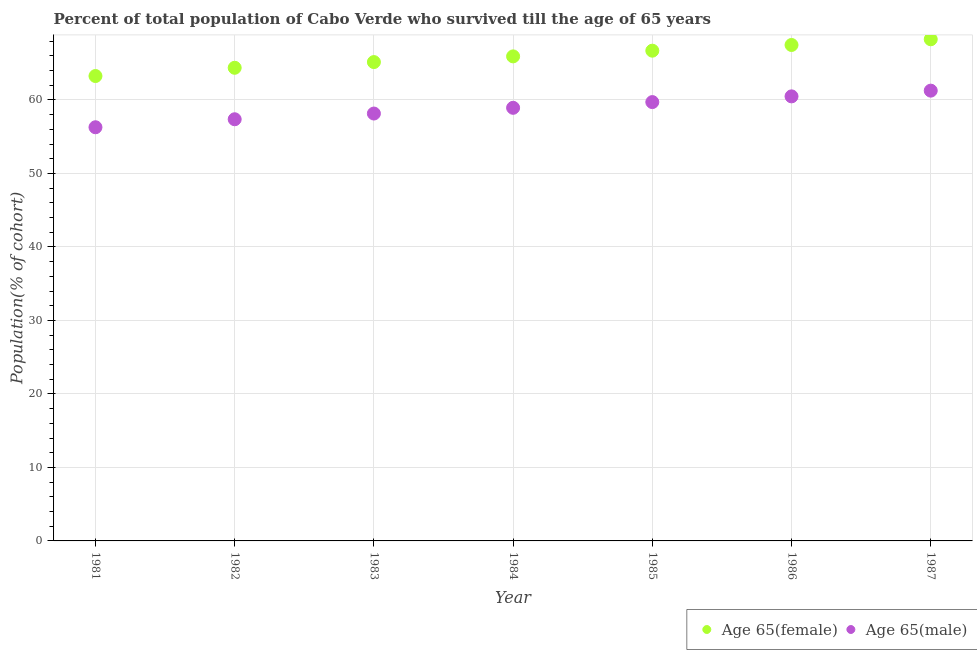Is the number of dotlines equal to the number of legend labels?
Provide a succinct answer. Yes. What is the percentage of male population who survived till age of 65 in 1983?
Keep it short and to the point. 58.16. Across all years, what is the maximum percentage of male population who survived till age of 65?
Your response must be concise. 61.27. Across all years, what is the minimum percentage of male population who survived till age of 65?
Provide a succinct answer. 56.29. In which year was the percentage of male population who survived till age of 65 minimum?
Provide a succinct answer. 1981. What is the total percentage of male population who survived till age of 65 in the graph?
Offer a very short reply. 412.24. What is the difference between the percentage of male population who survived till age of 65 in 1986 and that in 1987?
Keep it short and to the point. -0.78. What is the difference between the percentage of female population who survived till age of 65 in 1985 and the percentage of male population who survived till age of 65 in 1983?
Provide a short and direct response. 8.55. What is the average percentage of male population who survived till age of 65 per year?
Keep it short and to the point. 58.89. In the year 1984, what is the difference between the percentage of male population who survived till age of 65 and percentage of female population who survived till age of 65?
Offer a terse response. -7. What is the ratio of the percentage of female population who survived till age of 65 in 1984 to that in 1986?
Your response must be concise. 0.98. Is the percentage of female population who survived till age of 65 in 1983 less than that in 1984?
Make the answer very short. Yes. Is the difference between the percentage of male population who survived till age of 65 in 1982 and 1984 greater than the difference between the percentage of female population who survived till age of 65 in 1982 and 1984?
Provide a short and direct response. No. What is the difference between the highest and the second highest percentage of male population who survived till age of 65?
Give a very brief answer. 0.78. What is the difference between the highest and the lowest percentage of male population who survived till age of 65?
Provide a short and direct response. 4.98. Does the percentage of male population who survived till age of 65 monotonically increase over the years?
Ensure brevity in your answer.  Yes. Is the percentage of male population who survived till age of 65 strictly less than the percentage of female population who survived till age of 65 over the years?
Ensure brevity in your answer.  Yes. How many dotlines are there?
Provide a short and direct response. 2. Does the graph contain any zero values?
Provide a succinct answer. No. Does the graph contain grids?
Your answer should be very brief. Yes. Where does the legend appear in the graph?
Your answer should be compact. Bottom right. How many legend labels are there?
Your answer should be compact. 2. How are the legend labels stacked?
Give a very brief answer. Horizontal. What is the title of the graph?
Ensure brevity in your answer.  Percent of total population of Cabo Verde who survived till the age of 65 years. Does "Rural" appear as one of the legend labels in the graph?
Make the answer very short. No. What is the label or title of the X-axis?
Provide a succinct answer. Year. What is the label or title of the Y-axis?
Offer a terse response. Population(% of cohort). What is the Population(% of cohort) in Age 65(female) in 1981?
Your answer should be very brief. 63.26. What is the Population(% of cohort) in Age 65(male) in 1981?
Offer a terse response. 56.29. What is the Population(% of cohort) of Age 65(female) in 1982?
Make the answer very short. 64.38. What is the Population(% of cohort) of Age 65(male) in 1982?
Your response must be concise. 57.38. What is the Population(% of cohort) in Age 65(female) in 1983?
Your answer should be compact. 65.16. What is the Population(% of cohort) in Age 65(male) in 1983?
Offer a terse response. 58.16. What is the Population(% of cohort) of Age 65(female) in 1984?
Provide a short and direct response. 65.93. What is the Population(% of cohort) of Age 65(male) in 1984?
Make the answer very short. 58.93. What is the Population(% of cohort) in Age 65(female) in 1985?
Offer a very short reply. 66.71. What is the Population(% of cohort) in Age 65(male) in 1985?
Your response must be concise. 59.71. What is the Population(% of cohort) of Age 65(female) in 1986?
Your response must be concise. 67.49. What is the Population(% of cohort) in Age 65(male) in 1986?
Ensure brevity in your answer.  60.49. What is the Population(% of cohort) in Age 65(female) in 1987?
Ensure brevity in your answer.  68.26. What is the Population(% of cohort) in Age 65(male) in 1987?
Make the answer very short. 61.27. Across all years, what is the maximum Population(% of cohort) in Age 65(female)?
Offer a very short reply. 68.26. Across all years, what is the maximum Population(% of cohort) in Age 65(male)?
Your answer should be compact. 61.27. Across all years, what is the minimum Population(% of cohort) in Age 65(female)?
Offer a terse response. 63.26. Across all years, what is the minimum Population(% of cohort) in Age 65(male)?
Your answer should be compact. 56.29. What is the total Population(% of cohort) of Age 65(female) in the graph?
Give a very brief answer. 461.19. What is the total Population(% of cohort) of Age 65(male) in the graph?
Your answer should be very brief. 412.24. What is the difference between the Population(% of cohort) in Age 65(female) in 1981 and that in 1982?
Offer a terse response. -1.12. What is the difference between the Population(% of cohort) of Age 65(male) in 1981 and that in 1982?
Give a very brief answer. -1.09. What is the difference between the Population(% of cohort) of Age 65(female) in 1981 and that in 1983?
Give a very brief answer. -1.9. What is the difference between the Population(% of cohort) of Age 65(male) in 1981 and that in 1983?
Keep it short and to the point. -1.87. What is the difference between the Population(% of cohort) in Age 65(female) in 1981 and that in 1984?
Give a very brief answer. -2.67. What is the difference between the Population(% of cohort) in Age 65(male) in 1981 and that in 1984?
Your answer should be compact. -2.65. What is the difference between the Population(% of cohort) of Age 65(female) in 1981 and that in 1985?
Provide a short and direct response. -3.45. What is the difference between the Population(% of cohort) in Age 65(male) in 1981 and that in 1985?
Your response must be concise. -3.42. What is the difference between the Population(% of cohort) in Age 65(female) in 1981 and that in 1986?
Provide a short and direct response. -4.22. What is the difference between the Population(% of cohort) in Age 65(male) in 1981 and that in 1986?
Keep it short and to the point. -4.2. What is the difference between the Population(% of cohort) of Age 65(female) in 1981 and that in 1987?
Make the answer very short. -5. What is the difference between the Population(% of cohort) of Age 65(male) in 1981 and that in 1987?
Keep it short and to the point. -4.98. What is the difference between the Population(% of cohort) of Age 65(female) in 1982 and that in 1983?
Your answer should be very brief. -0.78. What is the difference between the Population(% of cohort) of Age 65(male) in 1982 and that in 1983?
Keep it short and to the point. -0.78. What is the difference between the Population(% of cohort) in Age 65(female) in 1982 and that in 1984?
Make the answer very short. -1.55. What is the difference between the Population(% of cohort) of Age 65(male) in 1982 and that in 1984?
Your answer should be very brief. -1.56. What is the difference between the Population(% of cohort) in Age 65(female) in 1982 and that in 1985?
Keep it short and to the point. -2.33. What is the difference between the Population(% of cohort) in Age 65(male) in 1982 and that in 1985?
Ensure brevity in your answer.  -2.34. What is the difference between the Population(% of cohort) in Age 65(female) in 1982 and that in 1986?
Your response must be concise. -3.1. What is the difference between the Population(% of cohort) in Age 65(male) in 1982 and that in 1986?
Your response must be concise. -3.12. What is the difference between the Population(% of cohort) of Age 65(female) in 1982 and that in 1987?
Give a very brief answer. -3.88. What is the difference between the Population(% of cohort) of Age 65(male) in 1982 and that in 1987?
Ensure brevity in your answer.  -3.89. What is the difference between the Population(% of cohort) of Age 65(female) in 1983 and that in 1984?
Your response must be concise. -0.78. What is the difference between the Population(% of cohort) in Age 65(male) in 1983 and that in 1984?
Offer a terse response. -0.78. What is the difference between the Population(% of cohort) in Age 65(female) in 1983 and that in 1985?
Keep it short and to the point. -1.55. What is the difference between the Population(% of cohort) in Age 65(male) in 1983 and that in 1985?
Provide a short and direct response. -1.56. What is the difference between the Population(% of cohort) of Age 65(female) in 1983 and that in 1986?
Offer a terse response. -2.33. What is the difference between the Population(% of cohort) in Age 65(male) in 1983 and that in 1986?
Your answer should be very brief. -2.34. What is the difference between the Population(% of cohort) of Age 65(female) in 1983 and that in 1987?
Provide a short and direct response. -3.1. What is the difference between the Population(% of cohort) in Age 65(male) in 1983 and that in 1987?
Your response must be concise. -3.12. What is the difference between the Population(% of cohort) in Age 65(female) in 1984 and that in 1985?
Your response must be concise. -0.78. What is the difference between the Population(% of cohort) in Age 65(male) in 1984 and that in 1985?
Keep it short and to the point. -0.78. What is the difference between the Population(% of cohort) in Age 65(female) in 1984 and that in 1986?
Provide a succinct answer. -1.55. What is the difference between the Population(% of cohort) in Age 65(male) in 1984 and that in 1986?
Provide a succinct answer. -1.56. What is the difference between the Population(% of cohort) in Age 65(female) in 1984 and that in 1987?
Your answer should be very brief. -2.33. What is the difference between the Population(% of cohort) of Age 65(male) in 1984 and that in 1987?
Your answer should be compact. -2.34. What is the difference between the Population(% of cohort) of Age 65(female) in 1985 and that in 1986?
Ensure brevity in your answer.  -0.78. What is the difference between the Population(% of cohort) of Age 65(male) in 1985 and that in 1986?
Provide a succinct answer. -0.78. What is the difference between the Population(% of cohort) of Age 65(female) in 1985 and that in 1987?
Provide a short and direct response. -1.55. What is the difference between the Population(% of cohort) of Age 65(male) in 1985 and that in 1987?
Make the answer very short. -1.56. What is the difference between the Population(% of cohort) in Age 65(female) in 1986 and that in 1987?
Keep it short and to the point. -0.78. What is the difference between the Population(% of cohort) in Age 65(male) in 1986 and that in 1987?
Keep it short and to the point. -0.78. What is the difference between the Population(% of cohort) in Age 65(female) in 1981 and the Population(% of cohort) in Age 65(male) in 1982?
Offer a very short reply. 5.88. What is the difference between the Population(% of cohort) in Age 65(female) in 1981 and the Population(% of cohort) in Age 65(male) in 1983?
Your answer should be very brief. 5.1. What is the difference between the Population(% of cohort) of Age 65(female) in 1981 and the Population(% of cohort) of Age 65(male) in 1984?
Give a very brief answer. 4.33. What is the difference between the Population(% of cohort) in Age 65(female) in 1981 and the Population(% of cohort) in Age 65(male) in 1985?
Provide a succinct answer. 3.55. What is the difference between the Population(% of cohort) in Age 65(female) in 1981 and the Population(% of cohort) in Age 65(male) in 1986?
Keep it short and to the point. 2.77. What is the difference between the Population(% of cohort) of Age 65(female) in 1981 and the Population(% of cohort) of Age 65(male) in 1987?
Provide a succinct answer. 1.99. What is the difference between the Population(% of cohort) of Age 65(female) in 1982 and the Population(% of cohort) of Age 65(male) in 1983?
Offer a terse response. 6.23. What is the difference between the Population(% of cohort) in Age 65(female) in 1982 and the Population(% of cohort) in Age 65(male) in 1984?
Give a very brief answer. 5.45. What is the difference between the Population(% of cohort) in Age 65(female) in 1982 and the Population(% of cohort) in Age 65(male) in 1985?
Give a very brief answer. 4.67. What is the difference between the Population(% of cohort) of Age 65(female) in 1982 and the Population(% of cohort) of Age 65(male) in 1986?
Give a very brief answer. 3.89. What is the difference between the Population(% of cohort) in Age 65(female) in 1982 and the Population(% of cohort) in Age 65(male) in 1987?
Your response must be concise. 3.11. What is the difference between the Population(% of cohort) in Age 65(female) in 1983 and the Population(% of cohort) in Age 65(male) in 1984?
Your answer should be very brief. 6.22. What is the difference between the Population(% of cohort) in Age 65(female) in 1983 and the Population(% of cohort) in Age 65(male) in 1985?
Your answer should be compact. 5.44. What is the difference between the Population(% of cohort) of Age 65(female) in 1983 and the Population(% of cohort) of Age 65(male) in 1986?
Your answer should be very brief. 4.67. What is the difference between the Population(% of cohort) in Age 65(female) in 1983 and the Population(% of cohort) in Age 65(male) in 1987?
Your response must be concise. 3.89. What is the difference between the Population(% of cohort) in Age 65(female) in 1984 and the Population(% of cohort) in Age 65(male) in 1985?
Provide a succinct answer. 6.22. What is the difference between the Population(% of cohort) of Age 65(female) in 1984 and the Population(% of cohort) of Age 65(male) in 1986?
Your answer should be compact. 5.44. What is the difference between the Population(% of cohort) of Age 65(female) in 1984 and the Population(% of cohort) of Age 65(male) in 1987?
Provide a succinct answer. 4.66. What is the difference between the Population(% of cohort) of Age 65(female) in 1985 and the Population(% of cohort) of Age 65(male) in 1986?
Your answer should be compact. 6.22. What is the difference between the Population(% of cohort) in Age 65(female) in 1985 and the Population(% of cohort) in Age 65(male) in 1987?
Provide a succinct answer. 5.44. What is the difference between the Population(% of cohort) in Age 65(female) in 1986 and the Population(% of cohort) in Age 65(male) in 1987?
Give a very brief answer. 6.21. What is the average Population(% of cohort) in Age 65(female) per year?
Offer a terse response. 65.88. What is the average Population(% of cohort) in Age 65(male) per year?
Provide a short and direct response. 58.89. In the year 1981, what is the difference between the Population(% of cohort) of Age 65(female) and Population(% of cohort) of Age 65(male)?
Offer a very short reply. 6.97. In the year 1982, what is the difference between the Population(% of cohort) in Age 65(female) and Population(% of cohort) in Age 65(male)?
Your answer should be compact. 7. In the year 1983, what is the difference between the Population(% of cohort) in Age 65(female) and Population(% of cohort) in Age 65(male)?
Keep it short and to the point. 7. In the year 1984, what is the difference between the Population(% of cohort) of Age 65(female) and Population(% of cohort) of Age 65(male)?
Your response must be concise. 7. In the year 1985, what is the difference between the Population(% of cohort) in Age 65(female) and Population(% of cohort) in Age 65(male)?
Provide a short and direct response. 7. In the year 1986, what is the difference between the Population(% of cohort) of Age 65(female) and Population(% of cohort) of Age 65(male)?
Provide a succinct answer. 6.99. In the year 1987, what is the difference between the Population(% of cohort) of Age 65(female) and Population(% of cohort) of Age 65(male)?
Give a very brief answer. 6.99. What is the ratio of the Population(% of cohort) of Age 65(female) in 1981 to that in 1982?
Offer a very short reply. 0.98. What is the ratio of the Population(% of cohort) in Age 65(female) in 1981 to that in 1983?
Your response must be concise. 0.97. What is the ratio of the Population(% of cohort) in Age 65(male) in 1981 to that in 1983?
Provide a succinct answer. 0.97. What is the ratio of the Population(% of cohort) of Age 65(female) in 1981 to that in 1984?
Offer a very short reply. 0.96. What is the ratio of the Population(% of cohort) in Age 65(male) in 1981 to that in 1984?
Your answer should be very brief. 0.96. What is the ratio of the Population(% of cohort) in Age 65(female) in 1981 to that in 1985?
Offer a very short reply. 0.95. What is the ratio of the Population(% of cohort) in Age 65(male) in 1981 to that in 1985?
Keep it short and to the point. 0.94. What is the ratio of the Population(% of cohort) in Age 65(female) in 1981 to that in 1986?
Your response must be concise. 0.94. What is the ratio of the Population(% of cohort) in Age 65(male) in 1981 to that in 1986?
Your answer should be very brief. 0.93. What is the ratio of the Population(% of cohort) in Age 65(female) in 1981 to that in 1987?
Offer a very short reply. 0.93. What is the ratio of the Population(% of cohort) in Age 65(male) in 1981 to that in 1987?
Provide a succinct answer. 0.92. What is the ratio of the Population(% of cohort) of Age 65(male) in 1982 to that in 1983?
Keep it short and to the point. 0.99. What is the ratio of the Population(% of cohort) in Age 65(female) in 1982 to that in 1984?
Your response must be concise. 0.98. What is the ratio of the Population(% of cohort) in Age 65(male) in 1982 to that in 1984?
Provide a succinct answer. 0.97. What is the ratio of the Population(% of cohort) in Age 65(female) in 1982 to that in 1985?
Your answer should be compact. 0.97. What is the ratio of the Population(% of cohort) of Age 65(male) in 1982 to that in 1985?
Your response must be concise. 0.96. What is the ratio of the Population(% of cohort) of Age 65(female) in 1982 to that in 1986?
Make the answer very short. 0.95. What is the ratio of the Population(% of cohort) of Age 65(male) in 1982 to that in 1986?
Ensure brevity in your answer.  0.95. What is the ratio of the Population(% of cohort) in Age 65(female) in 1982 to that in 1987?
Provide a short and direct response. 0.94. What is the ratio of the Population(% of cohort) of Age 65(male) in 1982 to that in 1987?
Make the answer very short. 0.94. What is the ratio of the Population(% of cohort) of Age 65(male) in 1983 to that in 1984?
Make the answer very short. 0.99. What is the ratio of the Population(% of cohort) in Age 65(female) in 1983 to that in 1985?
Offer a very short reply. 0.98. What is the ratio of the Population(% of cohort) in Age 65(male) in 1983 to that in 1985?
Ensure brevity in your answer.  0.97. What is the ratio of the Population(% of cohort) of Age 65(female) in 1983 to that in 1986?
Provide a short and direct response. 0.97. What is the ratio of the Population(% of cohort) in Age 65(male) in 1983 to that in 1986?
Offer a very short reply. 0.96. What is the ratio of the Population(% of cohort) of Age 65(female) in 1983 to that in 1987?
Make the answer very short. 0.95. What is the ratio of the Population(% of cohort) of Age 65(male) in 1983 to that in 1987?
Offer a very short reply. 0.95. What is the ratio of the Population(% of cohort) of Age 65(female) in 1984 to that in 1985?
Ensure brevity in your answer.  0.99. What is the ratio of the Population(% of cohort) of Age 65(male) in 1984 to that in 1985?
Provide a short and direct response. 0.99. What is the ratio of the Population(% of cohort) in Age 65(female) in 1984 to that in 1986?
Provide a short and direct response. 0.98. What is the ratio of the Population(% of cohort) of Age 65(male) in 1984 to that in 1986?
Your answer should be compact. 0.97. What is the ratio of the Population(% of cohort) of Age 65(female) in 1984 to that in 1987?
Your response must be concise. 0.97. What is the ratio of the Population(% of cohort) in Age 65(male) in 1984 to that in 1987?
Your answer should be compact. 0.96. What is the ratio of the Population(% of cohort) of Age 65(male) in 1985 to that in 1986?
Your answer should be compact. 0.99. What is the ratio of the Population(% of cohort) in Age 65(female) in 1985 to that in 1987?
Make the answer very short. 0.98. What is the ratio of the Population(% of cohort) in Age 65(male) in 1985 to that in 1987?
Your response must be concise. 0.97. What is the ratio of the Population(% of cohort) in Age 65(male) in 1986 to that in 1987?
Ensure brevity in your answer.  0.99. What is the difference between the highest and the second highest Population(% of cohort) in Age 65(female)?
Keep it short and to the point. 0.78. What is the difference between the highest and the second highest Population(% of cohort) of Age 65(male)?
Give a very brief answer. 0.78. What is the difference between the highest and the lowest Population(% of cohort) of Age 65(female)?
Offer a very short reply. 5. What is the difference between the highest and the lowest Population(% of cohort) in Age 65(male)?
Give a very brief answer. 4.98. 